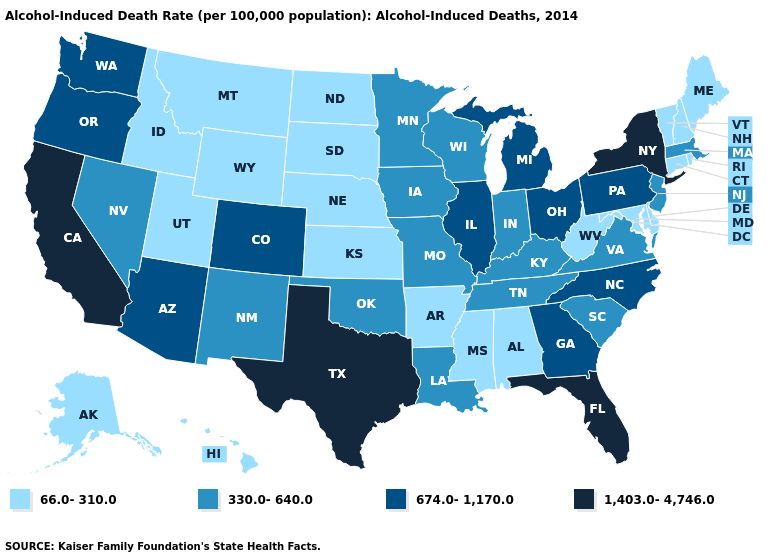Name the states that have a value in the range 330.0-640.0?
Keep it brief. Indiana, Iowa, Kentucky, Louisiana, Massachusetts, Minnesota, Missouri, Nevada, New Jersey, New Mexico, Oklahoma, South Carolina, Tennessee, Virginia, Wisconsin. What is the lowest value in the USA?
Keep it brief. 66.0-310.0. Does New York have the highest value in the Northeast?
Concise answer only. Yes. Name the states that have a value in the range 674.0-1,170.0?
Answer briefly. Arizona, Colorado, Georgia, Illinois, Michigan, North Carolina, Ohio, Oregon, Pennsylvania, Washington. Does the first symbol in the legend represent the smallest category?
Short answer required. Yes. What is the highest value in states that border Wyoming?
Give a very brief answer. 674.0-1,170.0. Name the states that have a value in the range 674.0-1,170.0?
Concise answer only. Arizona, Colorado, Georgia, Illinois, Michigan, North Carolina, Ohio, Oregon, Pennsylvania, Washington. What is the value of Wisconsin?
Concise answer only. 330.0-640.0. Among the states that border Kentucky , which have the lowest value?
Answer briefly. West Virginia. What is the lowest value in the USA?
Give a very brief answer. 66.0-310.0. What is the value of Minnesota?
Be succinct. 330.0-640.0. Which states hav the highest value in the Northeast?
Be succinct. New York. Which states have the lowest value in the West?
Write a very short answer. Alaska, Hawaii, Idaho, Montana, Utah, Wyoming. Name the states that have a value in the range 1,403.0-4,746.0?
Write a very short answer. California, Florida, New York, Texas. What is the highest value in the USA?
Quick response, please. 1,403.0-4,746.0. 